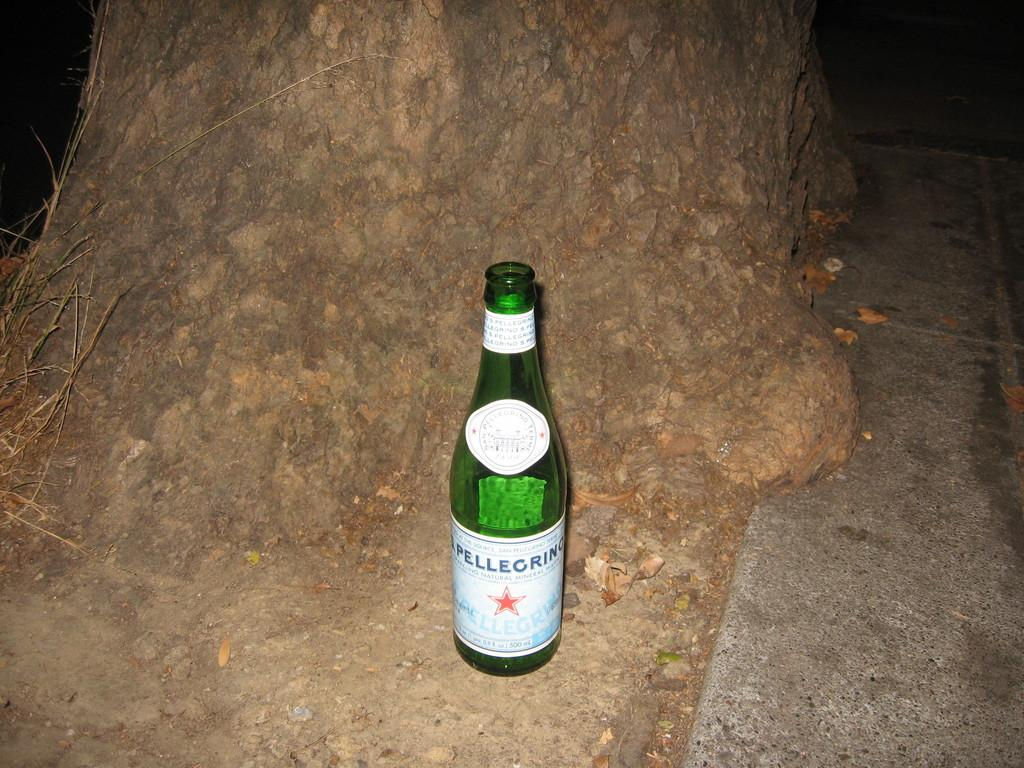Provide a one-sentence caption for the provided image. An open green bottle of Pellegrino sitting outside at night. 